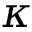<formula> <loc_0><loc_0><loc_500><loc_500>\kappa</formula> 